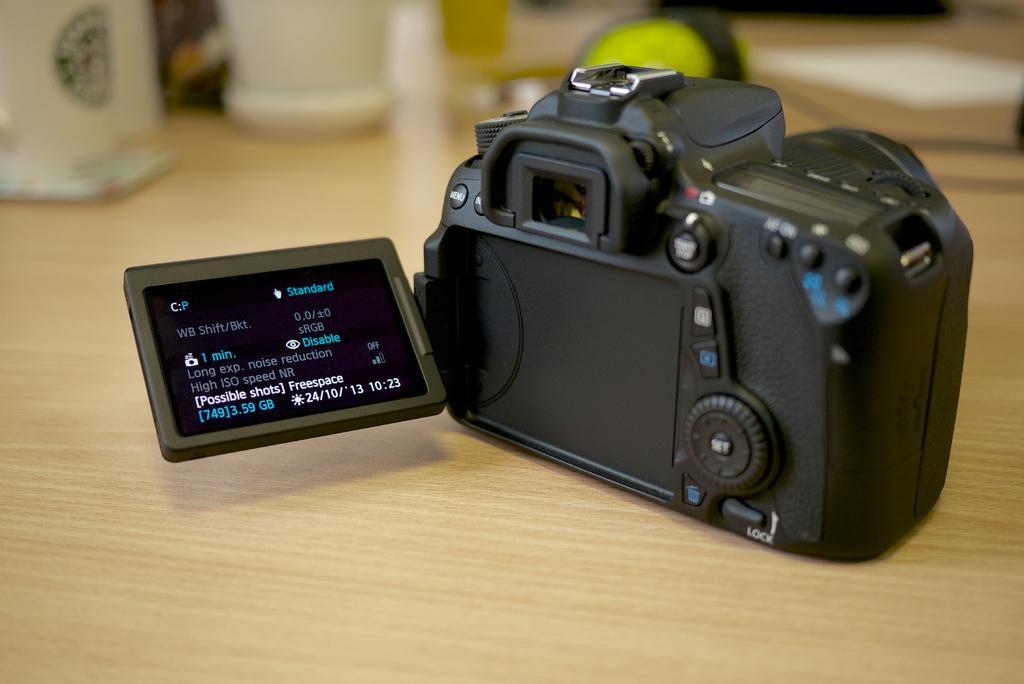How would you summarize this image in a sentence or two? In this picture we can see a camera placed along with few objects are placed on the table. 